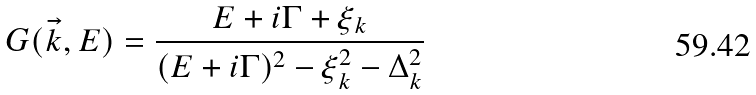<formula> <loc_0><loc_0><loc_500><loc_500>G ( \vec { k } , E ) = \frac { E + i \Gamma + \xi _ { k } } { ( E + i \Gamma ) ^ { 2 } - \xi _ { k } ^ { 2 } - \Delta _ { k } ^ { 2 } }</formula> 